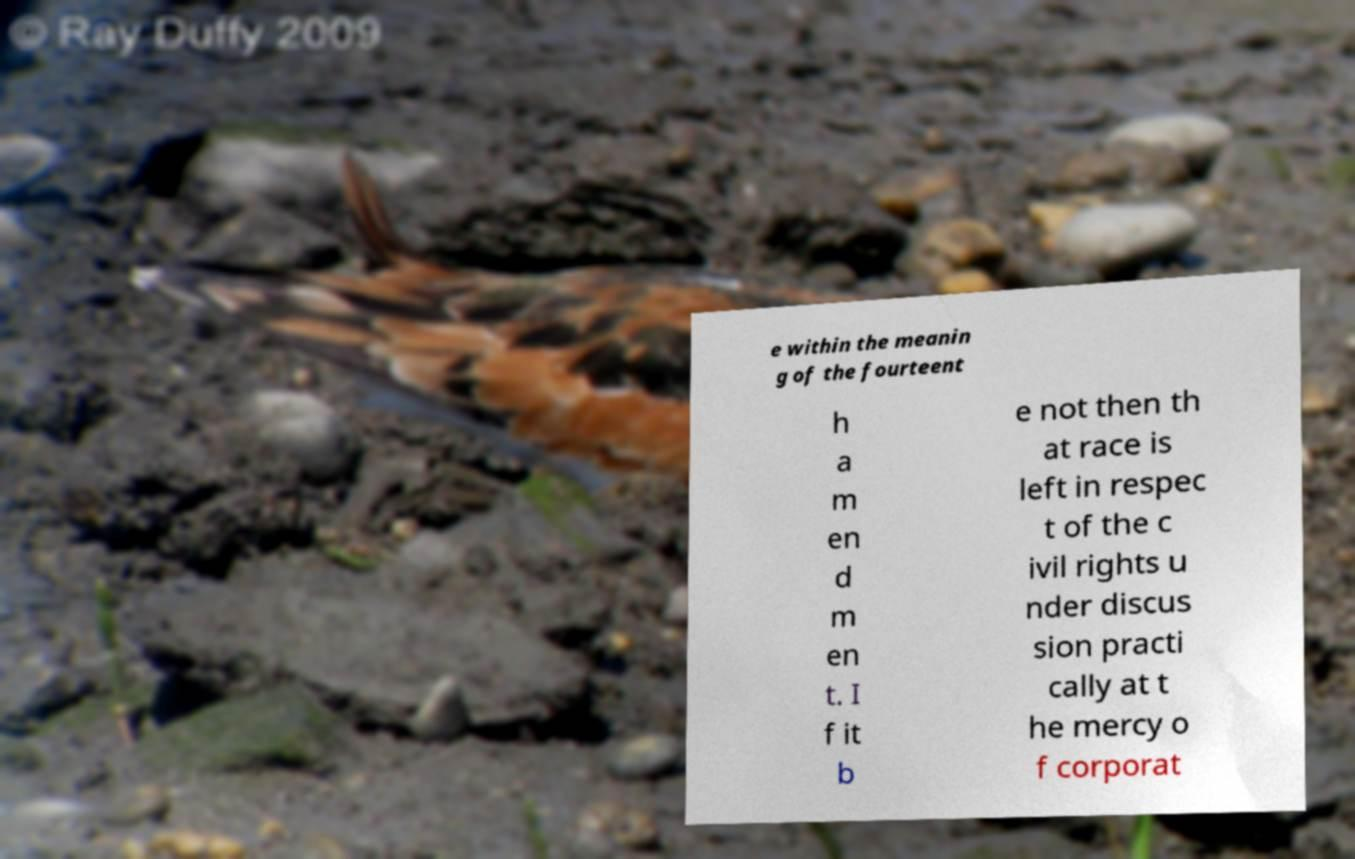I need the written content from this picture converted into text. Can you do that? e within the meanin g of the fourteent h a m en d m en t. I f it b e not then th at race is left in respec t of the c ivil rights u nder discus sion practi cally at t he mercy o f corporat 